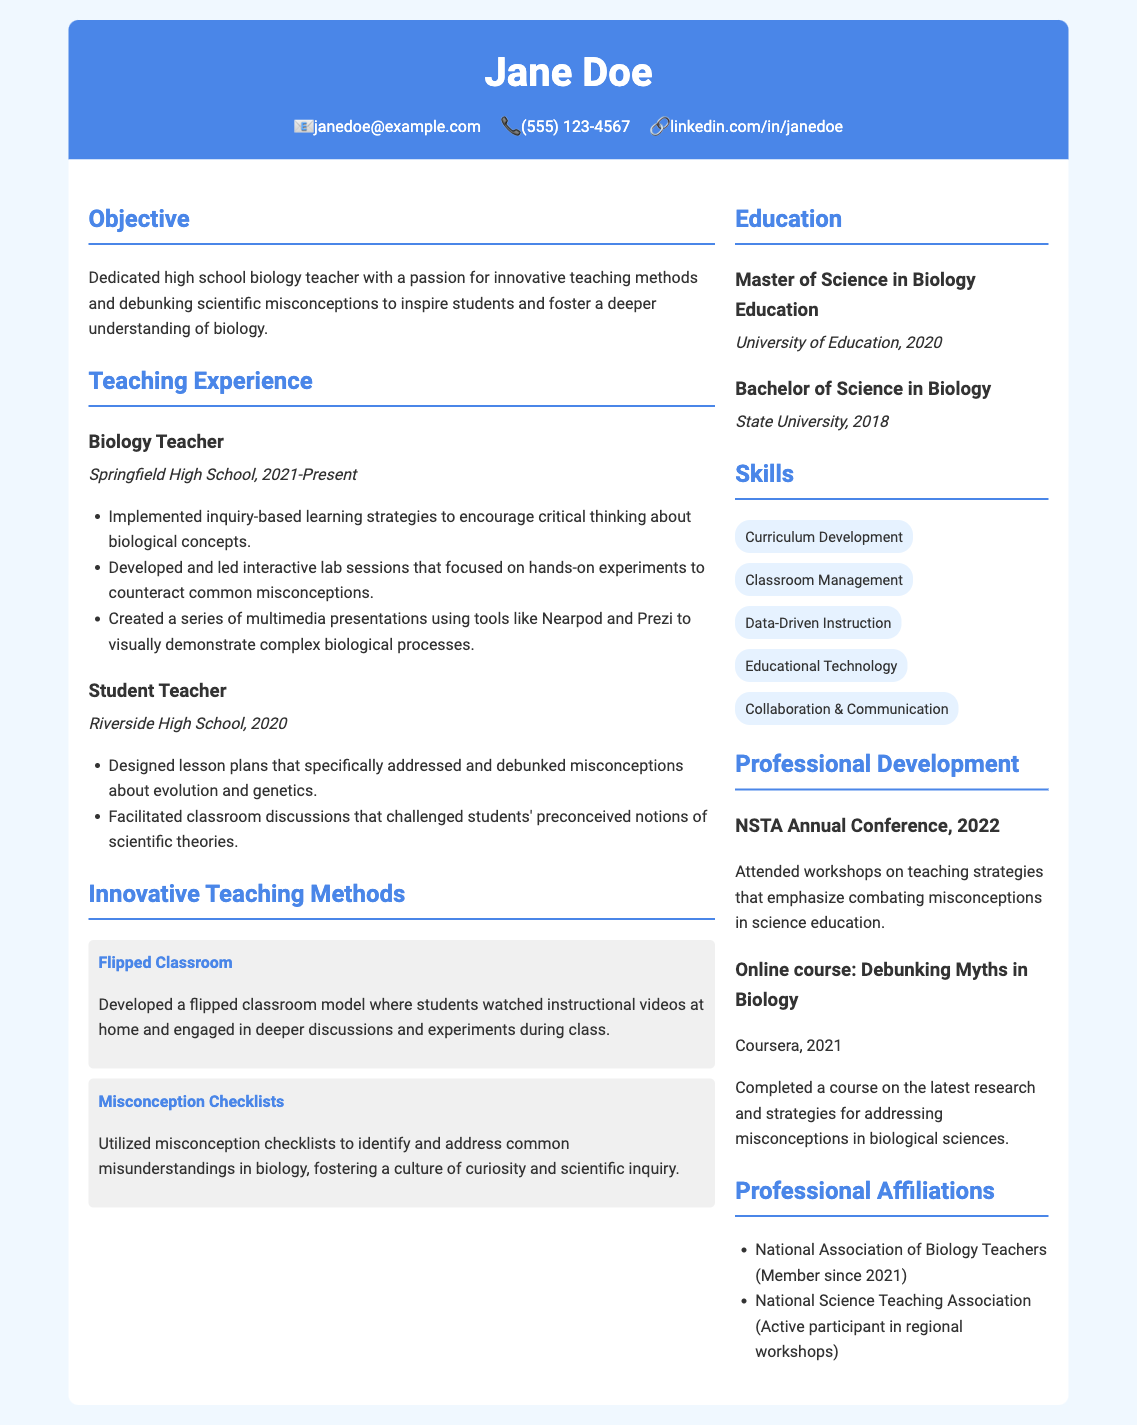What is the name of the biology teacher? The document states that the biology teacher's name is Jane Doe.
Answer: Jane Doe In which school is Jane Doe currently teaching? The document indicates that Jane Doe is currently teaching at Springfield High School.
Answer: Springfield High School What innovative teaching method did Jane Doe develop? The document mentions that Jane Doe developed a flipped classroom model.
Answer: Flipped Classroom What degree did Jane Doe earn in 2020? The document lists that Jane Doe earned a Master of Science in Biology Education in 2020.
Answer: Master of Science in Biology Education Which year did Jane Doe complete her Bachelor of Science degree? The document indicates that Jane Doe completed her Bachelor of Science in Biology in 2018.
Answer: 2018 What is one method used to address misconceptions in biology? The document outlines that Jane Doe utilized misconception checklists to address misunderstandings in biology.
Answer: Misconception Checklists How many years has Jane Doe been a member of the National Association of Biology Teachers? The document states that Jane Doe has been a member since 2021, indicating her membership duration relative to the current year would depend on the current date, assumed as 2023 in this case, which is 2 years.
Answer: 2 years What conference did Jane Doe attend in 2022? The document mentions that Jane Doe attended the NSTA Annual Conference in 2022.
Answer: NSTA Annual Conference What are the skills listed for Jane Doe? The document includes skills such as Curriculum Development, Classroom Management, and Data-Driven Instruction among others.
Answer: Curriculum Development, Classroom Management, Data-Driven Instruction 